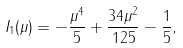<formula> <loc_0><loc_0><loc_500><loc_500>I _ { 1 } ( \mu ) = - \frac { \mu ^ { 4 } } { 5 } + \frac { 3 4 \mu ^ { 2 } } { 1 2 5 } - \frac { 1 } { 5 } ,</formula> 